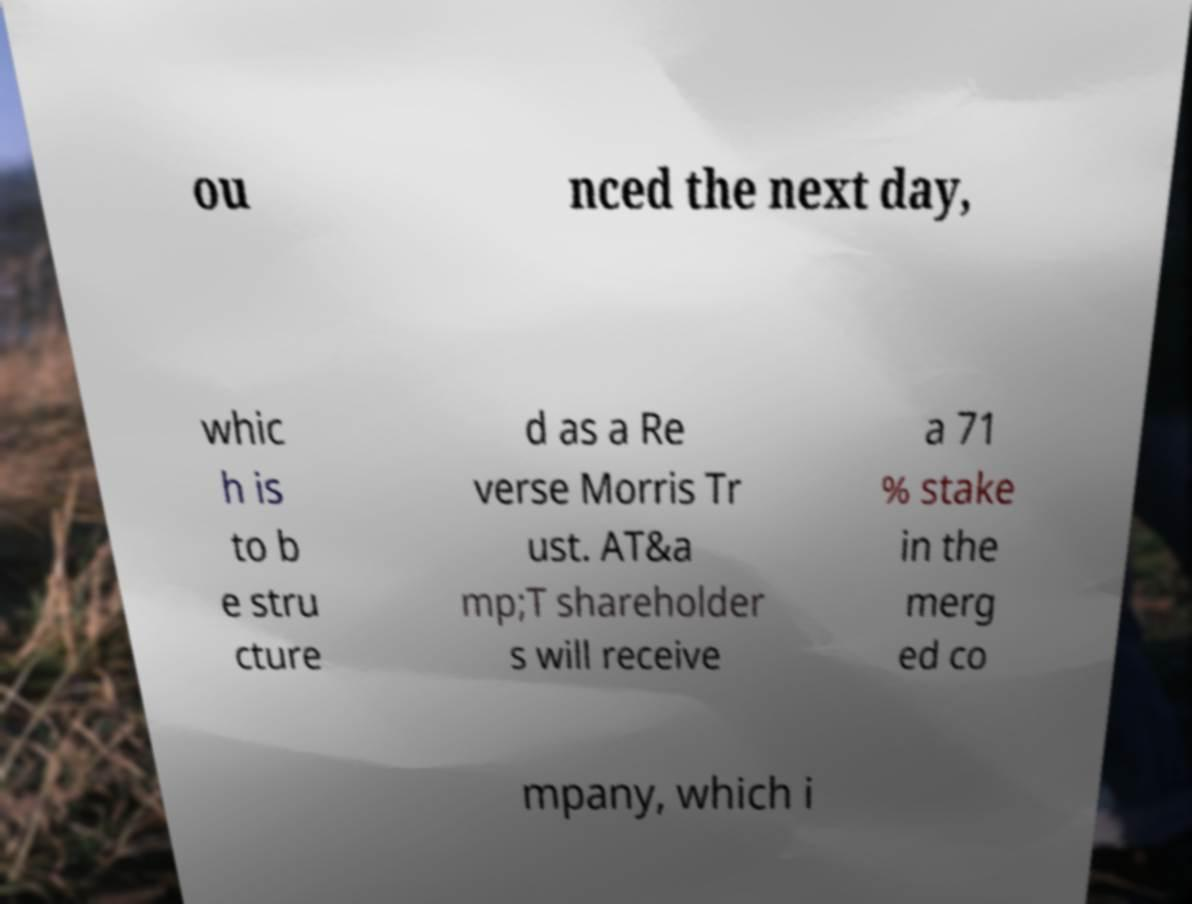Please identify and transcribe the text found in this image. ou nced the next day, whic h is to b e stru cture d as a Re verse Morris Tr ust. AT&a mp;T shareholder s will receive a 71 % stake in the merg ed co mpany, which i 